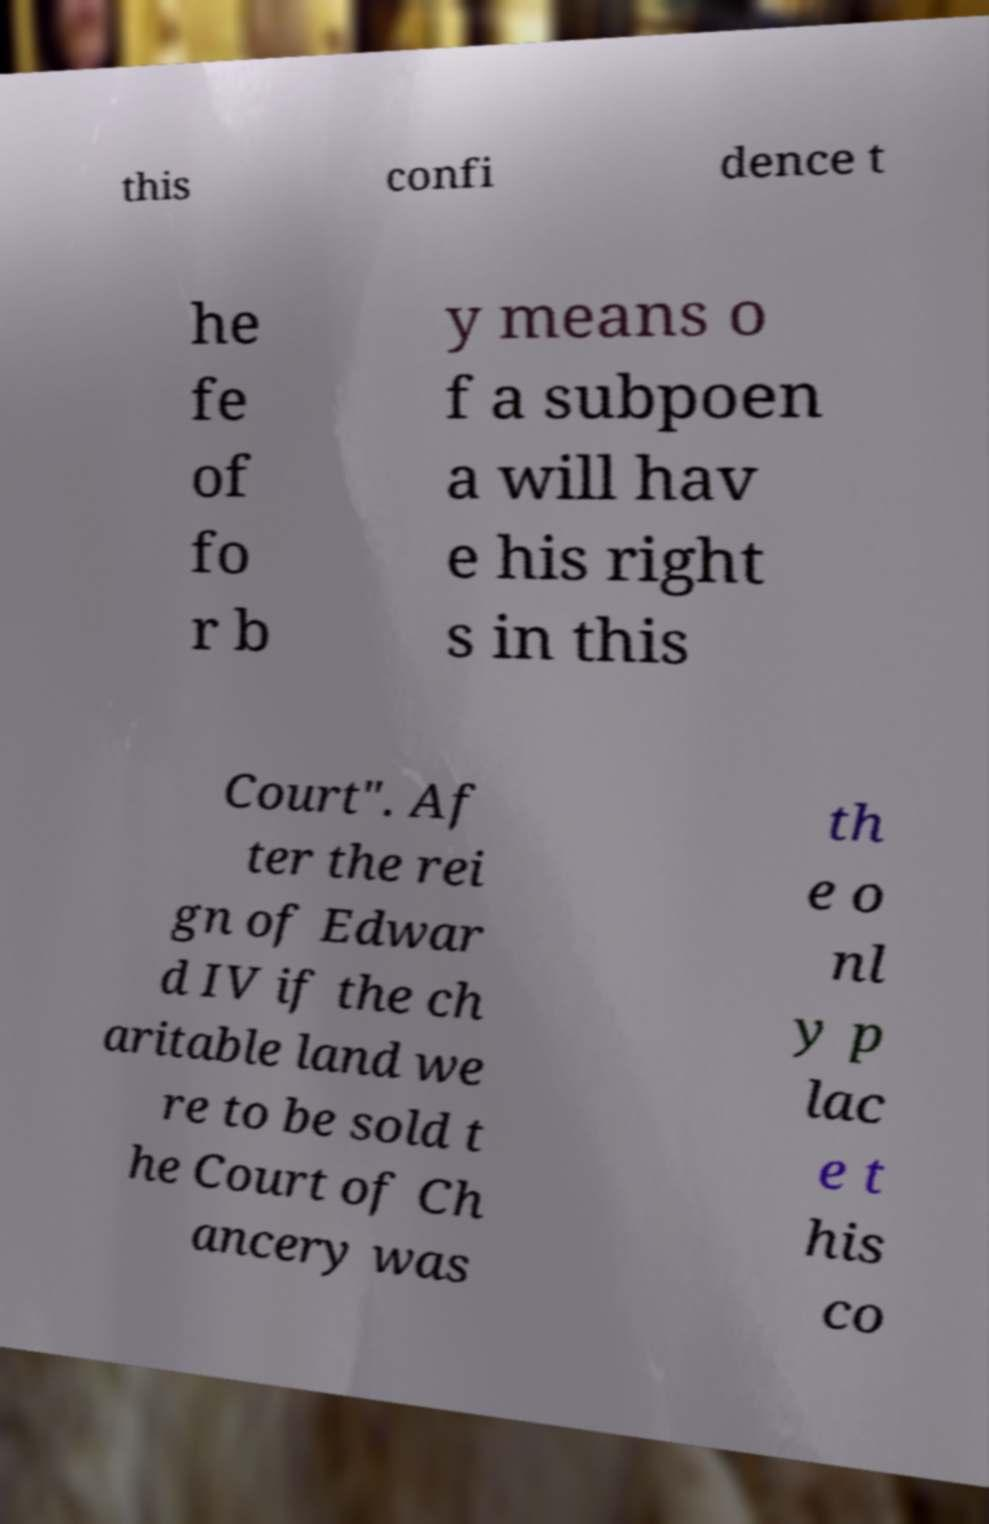Please identify and transcribe the text found in this image. this confi dence t he fe of fo r b y means o f a subpoen a will hav e his right s in this Court". Af ter the rei gn of Edwar d IV if the ch aritable land we re to be sold t he Court of Ch ancery was th e o nl y p lac e t his co 